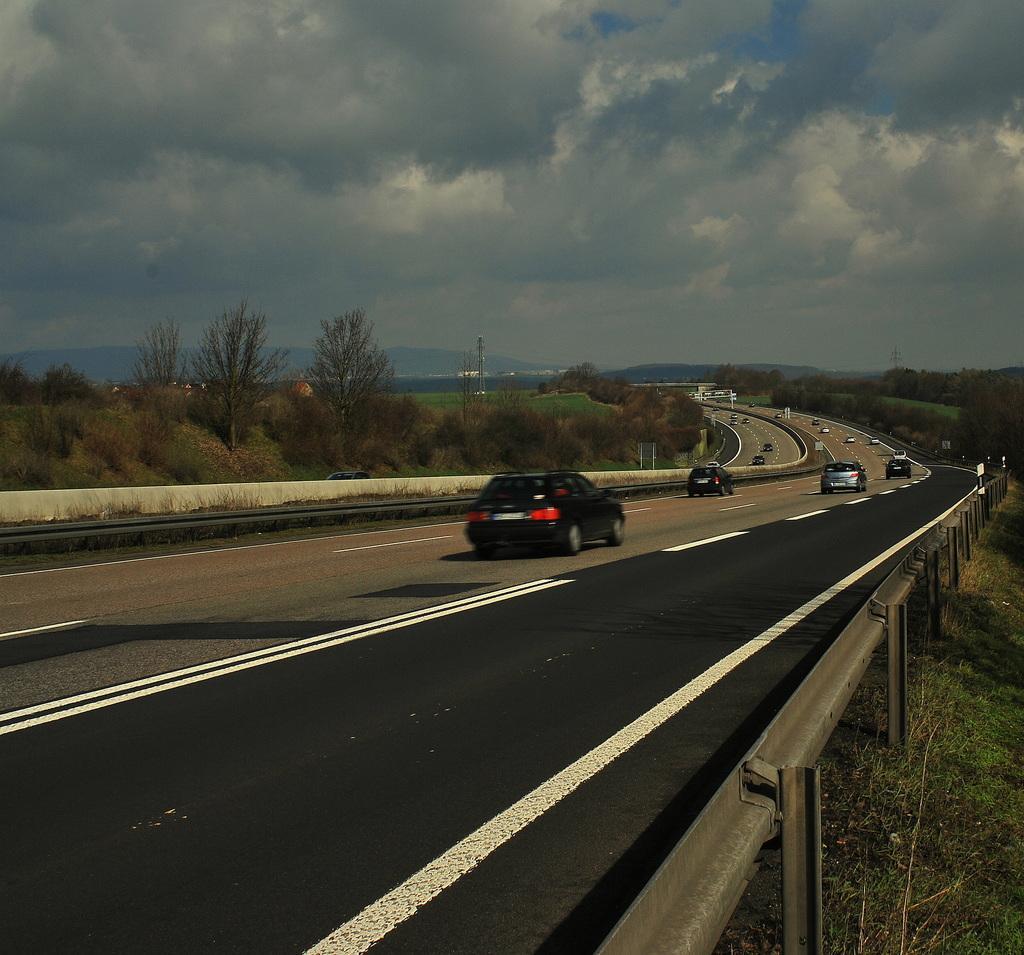In one or two sentences, can you explain what this image depicts? In this image few cars and vehicles are on the road. Right side there is a fence on the land having grass. Left side there are few plants and trees on the land. There is a tower. Behind there are hills. Top of image there is sky with some clouds. 